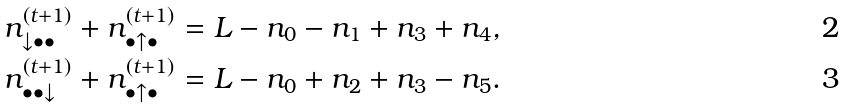Convert formula to latex. <formula><loc_0><loc_0><loc_500><loc_500>n _ { \downarrow \bullet \bullet } ^ { ( t + 1 ) } + n _ { \bullet \uparrow \bullet } ^ { ( t + 1 ) } & = L - n _ { 0 } - n _ { 1 } + n _ { 3 } + n _ { 4 } , \\ n _ { \bullet \bullet \downarrow } ^ { ( t + 1 ) } + n _ { \bullet \uparrow \bullet } ^ { ( t + 1 ) } & = L - n _ { 0 } + n _ { 2 } + n _ { 3 } - n _ { 5 } .</formula> 